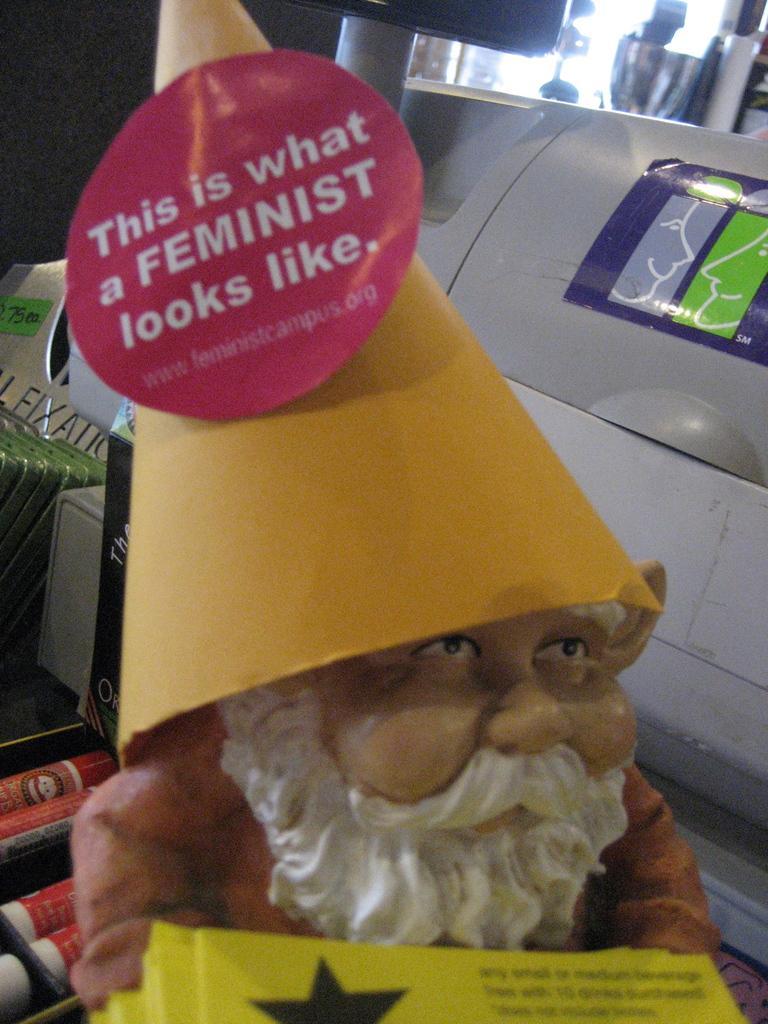Can you describe this image briefly? In the center of the image there is a toy. In the background we can see objects and wall. 